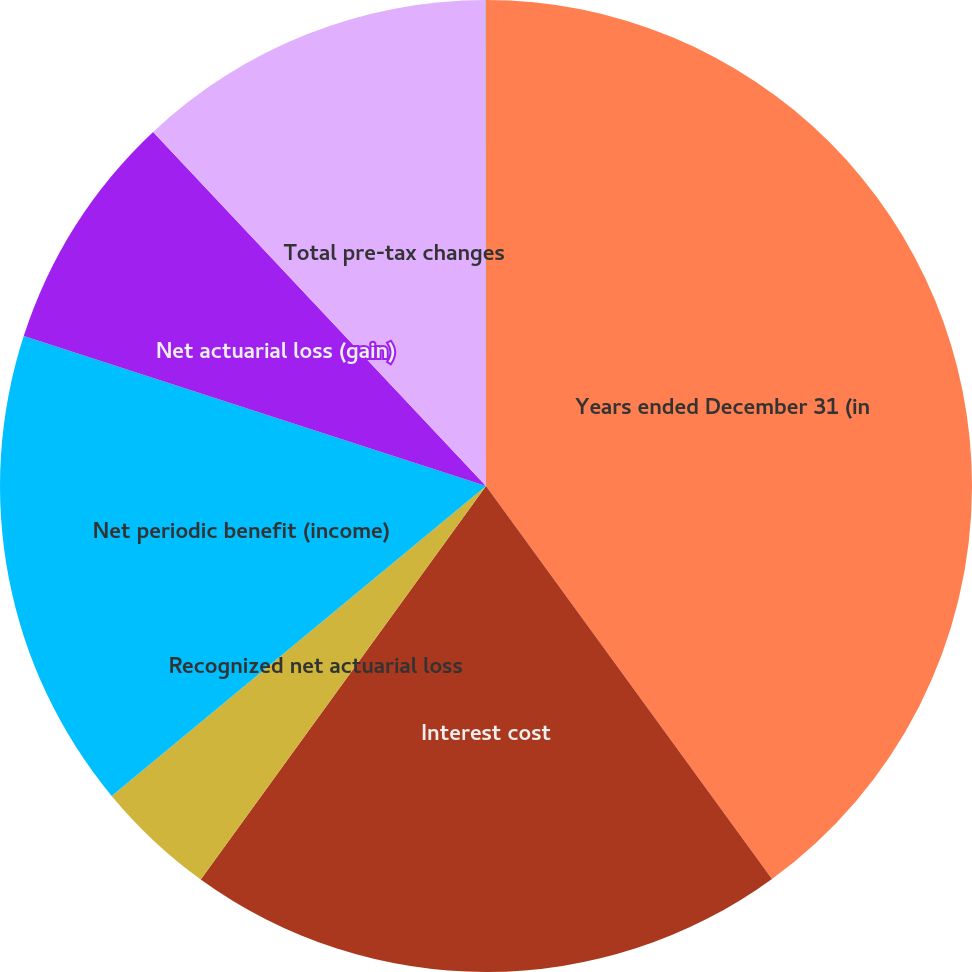<chart> <loc_0><loc_0><loc_500><loc_500><pie_chart><fcel>Years ended December 31 (in<fcel>Interest cost<fcel>Recognized net actuarial loss<fcel>Net periodic benefit (income)<fcel>Net actuarial loss (gain)<fcel>Total pre-tax changes<fcel>Total recognized in net<nl><fcel>39.99%<fcel>20.0%<fcel>4.01%<fcel>16.0%<fcel>8.0%<fcel>12.0%<fcel>0.01%<nl></chart> 